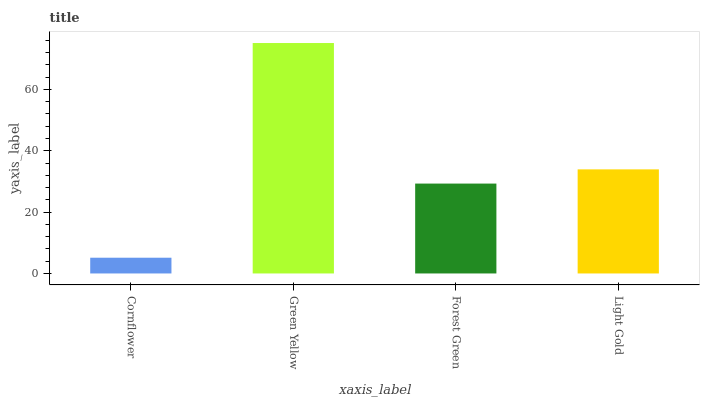Is Cornflower the minimum?
Answer yes or no. Yes. Is Green Yellow the maximum?
Answer yes or no. Yes. Is Forest Green the minimum?
Answer yes or no. No. Is Forest Green the maximum?
Answer yes or no. No. Is Green Yellow greater than Forest Green?
Answer yes or no. Yes. Is Forest Green less than Green Yellow?
Answer yes or no. Yes. Is Forest Green greater than Green Yellow?
Answer yes or no. No. Is Green Yellow less than Forest Green?
Answer yes or no. No. Is Light Gold the high median?
Answer yes or no. Yes. Is Forest Green the low median?
Answer yes or no. Yes. Is Cornflower the high median?
Answer yes or no. No. Is Green Yellow the low median?
Answer yes or no. No. 